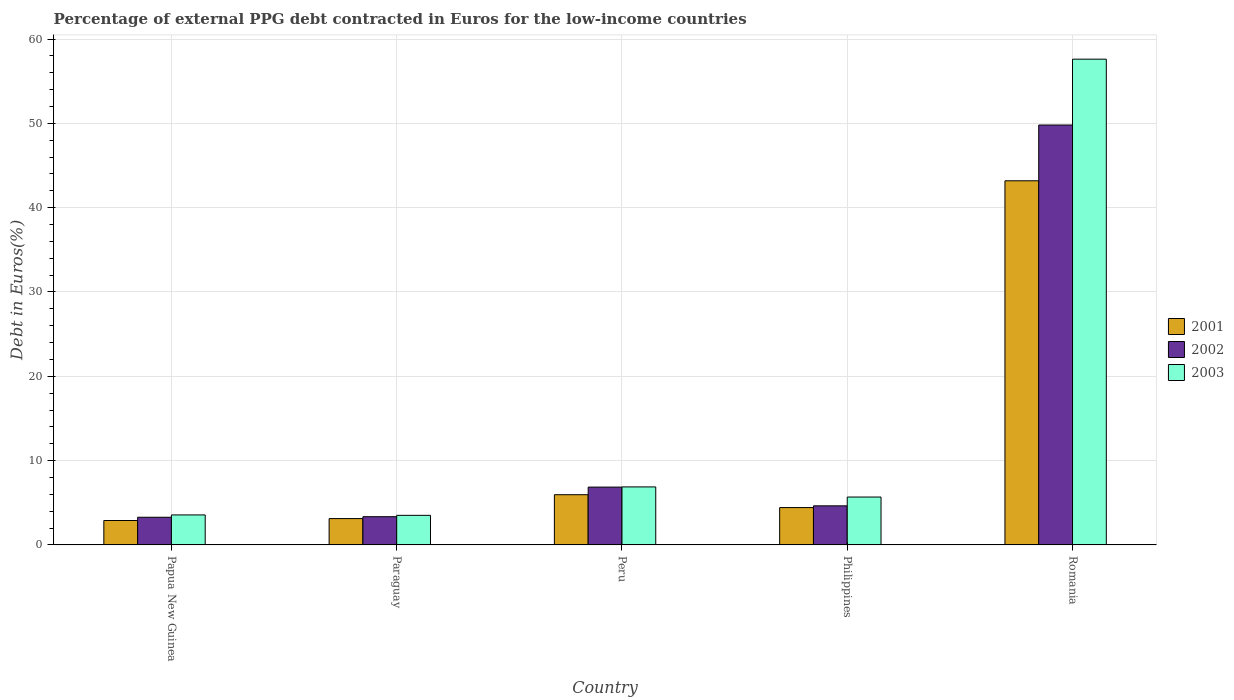Are the number of bars per tick equal to the number of legend labels?
Make the answer very short. Yes. Are the number of bars on each tick of the X-axis equal?
Provide a succinct answer. Yes. How many bars are there on the 3rd tick from the left?
Ensure brevity in your answer.  3. What is the label of the 2nd group of bars from the left?
Provide a short and direct response. Paraguay. In how many cases, is the number of bars for a given country not equal to the number of legend labels?
Ensure brevity in your answer.  0. What is the percentage of external PPG debt contracted in Euros in 2002 in Philippines?
Provide a succinct answer. 4.64. Across all countries, what is the maximum percentage of external PPG debt contracted in Euros in 2002?
Your answer should be compact. 49.8. Across all countries, what is the minimum percentage of external PPG debt contracted in Euros in 2002?
Your answer should be very brief. 3.28. In which country was the percentage of external PPG debt contracted in Euros in 2003 maximum?
Provide a short and direct response. Romania. In which country was the percentage of external PPG debt contracted in Euros in 2002 minimum?
Ensure brevity in your answer.  Papua New Guinea. What is the total percentage of external PPG debt contracted in Euros in 2001 in the graph?
Give a very brief answer. 59.6. What is the difference between the percentage of external PPG debt contracted in Euros in 2003 in Papua New Guinea and that in Romania?
Your answer should be very brief. -54.06. What is the difference between the percentage of external PPG debt contracted in Euros in 2001 in Romania and the percentage of external PPG debt contracted in Euros in 2002 in Paraguay?
Your answer should be compact. 39.84. What is the average percentage of external PPG debt contracted in Euros in 2003 per country?
Offer a terse response. 15.45. What is the difference between the percentage of external PPG debt contracted in Euros of/in 2002 and percentage of external PPG debt contracted in Euros of/in 2001 in Peru?
Your answer should be very brief. 0.9. What is the ratio of the percentage of external PPG debt contracted in Euros in 2002 in Philippines to that in Romania?
Provide a succinct answer. 0.09. Is the difference between the percentage of external PPG debt contracted in Euros in 2002 in Papua New Guinea and Romania greater than the difference between the percentage of external PPG debt contracted in Euros in 2001 in Papua New Guinea and Romania?
Offer a terse response. No. What is the difference between the highest and the second highest percentage of external PPG debt contracted in Euros in 2002?
Give a very brief answer. 45.17. What is the difference between the highest and the lowest percentage of external PPG debt contracted in Euros in 2003?
Your response must be concise. 54.1. In how many countries, is the percentage of external PPG debt contracted in Euros in 2003 greater than the average percentage of external PPG debt contracted in Euros in 2003 taken over all countries?
Keep it short and to the point. 1. What does the 1st bar from the left in Philippines represents?
Your answer should be compact. 2001. What does the 2nd bar from the right in Romania represents?
Your response must be concise. 2002. Are all the bars in the graph horizontal?
Provide a short and direct response. No. How many countries are there in the graph?
Ensure brevity in your answer.  5. What is the difference between two consecutive major ticks on the Y-axis?
Give a very brief answer. 10. Where does the legend appear in the graph?
Your answer should be very brief. Center right. What is the title of the graph?
Make the answer very short. Percentage of external PPG debt contracted in Euros for the low-income countries. What is the label or title of the Y-axis?
Provide a short and direct response. Debt in Euros(%). What is the Debt in Euros(%) of 2001 in Papua New Guinea?
Offer a very short reply. 2.9. What is the Debt in Euros(%) in 2002 in Papua New Guinea?
Your answer should be very brief. 3.28. What is the Debt in Euros(%) of 2003 in Papua New Guinea?
Keep it short and to the point. 3.56. What is the Debt in Euros(%) in 2001 in Paraguay?
Offer a terse response. 3.12. What is the Debt in Euros(%) in 2002 in Paraguay?
Offer a very short reply. 3.35. What is the Debt in Euros(%) of 2003 in Paraguay?
Provide a succinct answer. 3.51. What is the Debt in Euros(%) of 2001 in Peru?
Your answer should be compact. 5.96. What is the Debt in Euros(%) of 2002 in Peru?
Offer a very short reply. 6.86. What is the Debt in Euros(%) of 2003 in Peru?
Provide a succinct answer. 6.88. What is the Debt in Euros(%) of 2001 in Philippines?
Offer a terse response. 4.43. What is the Debt in Euros(%) of 2002 in Philippines?
Offer a terse response. 4.64. What is the Debt in Euros(%) in 2003 in Philippines?
Offer a very short reply. 5.68. What is the Debt in Euros(%) of 2001 in Romania?
Offer a very short reply. 43.19. What is the Debt in Euros(%) of 2002 in Romania?
Ensure brevity in your answer.  49.8. What is the Debt in Euros(%) of 2003 in Romania?
Your answer should be compact. 57.61. Across all countries, what is the maximum Debt in Euros(%) of 2001?
Provide a short and direct response. 43.19. Across all countries, what is the maximum Debt in Euros(%) of 2002?
Your answer should be very brief. 49.8. Across all countries, what is the maximum Debt in Euros(%) in 2003?
Your answer should be very brief. 57.61. Across all countries, what is the minimum Debt in Euros(%) in 2001?
Your response must be concise. 2.9. Across all countries, what is the minimum Debt in Euros(%) in 2002?
Provide a short and direct response. 3.28. Across all countries, what is the minimum Debt in Euros(%) of 2003?
Make the answer very short. 3.51. What is the total Debt in Euros(%) in 2001 in the graph?
Offer a very short reply. 59.6. What is the total Debt in Euros(%) in 2002 in the graph?
Give a very brief answer. 67.93. What is the total Debt in Euros(%) of 2003 in the graph?
Provide a short and direct response. 77.24. What is the difference between the Debt in Euros(%) in 2001 in Papua New Guinea and that in Paraguay?
Your response must be concise. -0.23. What is the difference between the Debt in Euros(%) of 2002 in Papua New Guinea and that in Paraguay?
Give a very brief answer. -0.07. What is the difference between the Debt in Euros(%) of 2003 in Papua New Guinea and that in Paraguay?
Offer a terse response. 0.05. What is the difference between the Debt in Euros(%) in 2001 in Papua New Guinea and that in Peru?
Provide a succinct answer. -3.06. What is the difference between the Debt in Euros(%) of 2002 in Papua New Guinea and that in Peru?
Offer a terse response. -3.58. What is the difference between the Debt in Euros(%) in 2003 in Papua New Guinea and that in Peru?
Give a very brief answer. -3.32. What is the difference between the Debt in Euros(%) of 2001 in Papua New Guinea and that in Philippines?
Provide a short and direct response. -1.53. What is the difference between the Debt in Euros(%) of 2002 in Papua New Guinea and that in Philippines?
Offer a terse response. -1.35. What is the difference between the Debt in Euros(%) in 2003 in Papua New Guinea and that in Philippines?
Provide a succinct answer. -2.12. What is the difference between the Debt in Euros(%) in 2001 in Papua New Guinea and that in Romania?
Give a very brief answer. -40.29. What is the difference between the Debt in Euros(%) in 2002 in Papua New Guinea and that in Romania?
Your answer should be very brief. -46.52. What is the difference between the Debt in Euros(%) in 2003 in Papua New Guinea and that in Romania?
Give a very brief answer. -54.06. What is the difference between the Debt in Euros(%) in 2001 in Paraguay and that in Peru?
Your answer should be compact. -2.83. What is the difference between the Debt in Euros(%) in 2002 in Paraguay and that in Peru?
Provide a succinct answer. -3.51. What is the difference between the Debt in Euros(%) in 2003 in Paraguay and that in Peru?
Make the answer very short. -3.37. What is the difference between the Debt in Euros(%) of 2001 in Paraguay and that in Philippines?
Offer a terse response. -1.31. What is the difference between the Debt in Euros(%) of 2002 in Paraguay and that in Philippines?
Give a very brief answer. -1.29. What is the difference between the Debt in Euros(%) in 2003 in Paraguay and that in Philippines?
Make the answer very short. -2.17. What is the difference between the Debt in Euros(%) in 2001 in Paraguay and that in Romania?
Your response must be concise. -40.06. What is the difference between the Debt in Euros(%) of 2002 in Paraguay and that in Romania?
Make the answer very short. -46.45. What is the difference between the Debt in Euros(%) of 2003 in Paraguay and that in Romania?
Provide a short and direct response. -54.1. What is the difference between the Debt in Euros(%) of 2001 in Peru and that in Philippines?
Provide a short and direct response. 1.53. What is the difference between the Debt in Euros(%) in 2002 in Peru and that in Philippines?
Give a very brief answer. 2.22. What is the difference between the Debt in Euros(%) in 2003 in Peru and that in Philippines?
Ensure brevity in your answer.  1.2. What is the difference between the Debt in Euros(%) of 2001 in Peru and that in Romania?
Offer a terse response. -37.23. What is the difference between the Debt in Euros(%) in 2002 in Peru and that in Romania?
Your answer should be compact. -42.94. What is the difference between the Debt in Euros(%) in 2003 in Peru and that in Romania?
Make the answer very short. -50.73. What is the difference between the Debt in Euros(%) of 2001 in Philippines and that in Romania?
Offer a terse response. -38.76. What is the difference between the Debt in Euros(%) in 2002 in Philippines and that in Romania?
Keep it short and to the point. -45.17. What is the difference between the Debt in Euros(%) of 2003 in Philippines and that in Romania?
Offer a very short reply. -51.93. What is the difference between the Debt in Euros(%) of 2001 in Papua New Guinea and the Debt in Euros(%) of 2002 in Paraguay?
Provide a short and direct response. -0.45. What is the difference between the Debt in Euros(%) in 2001 in Papua New Guinea and the Debt in Euros(%) in 2003 in Paraguay?
Your answer should be compact. -0.61. What is the difference between the Debt in Euros(%) in 2002 in Papua New Guinea and the Debt in Euros(%) in 2003 in Paraguay?
Offer a terse response. -0.23. What is the difference between the Debt in Euros(%) in 2001 in Papua New Guinea and the Debt in Euros(%) in 2002 in Peru?
Your response must be concise. -3.96. What is the difference between the Debt in Euros(%) in 2001 in Papua New Guinea and the Debt in Euros(%) in 2003 in Peru?
Ensure brevity in your answer.  -3.98. What is the difference between the Debt in Euros(%) of 2002 in Papua New Guinea and the Debt in Euros(%) of 2003 in Peru?
Make the answer very short. -3.6. What is the difference between the Debt in Euros(%) in 2001 in Papua New Guinea and the Debt in Euros(%) in 2002 in Philippines?
Your answer should be compact. -1.74. What is the difference between the Debt in Euros(%) in 2001 in Papua New Guinea and the Debt in Euros(%) in 2003 in Philippines?
Ensure brevity in your answer.  -2.78. What is the difference between the Debt in Euros(%) of 2002 in Papua New Guinea and the Debt in Euros(%) of 2003 in Philippines?
Your answer should be very brief. -2.4. What is the difference between the Debt in Euros(%) of 2001 in Papua New Guinea and the Debt in Euros(%) of 2002 in Romania?
Your answer should be very brief. -46.91. What is the difference between the Debt in Euros(%) of 2001 in Papua New Guinea and the Debt in Euros(%) of 2003 in Romania?
Offer a terse response. -54.72. What is the difference between the Debt in Euros(%) of 2002 in Papua New Guinea and the Debt in Euros(%) of 2003 in Romania?
Give a very brief answer. -54.33. What is the difference between the Debt in Euros(%) of 2001 in Paraguay and the Debt in Euros(%) of 2002 in Peru?
Your response must be concise. -3.73. What is the difference between the Debt in Euros(%) in 2001 in Paraguay and the Debt in Euros(%) in 2003 in Peru?
Offer a terse response. -3.76. What is the difference between the Debt in Euros(%) of 2002 in Paraguay and the Debt in Euros(%) of 2003 in Peru?
Make the answer very short. -3.53. What is the difference between the Debt in Euros(%) of 2001 in Paraguay and the Debt in Euros(%) of 2002 in Philippines?
Your answer should be very brief. -1.51. What is the difference between the Debt in Euros(%) of 2001 in Paraguay and the Debt in Euros(%) of 2003 in Philippines?
Your answer should be very brief. -2.56. What is the difference between the Debt in Euros(%) in 2002 in Paraguay and the Debt in Euros(%) in 2003 in Philippines?
Keep it short and to the point. -2.33. What is the difference between the Debt in Euros(%) in 2001 in Paraguay and the Debt in Euros(%) in 2002 in Romania?
Keep it short and to the point. -46.68. What is the difference between the Debt in Euros(%) in 2001 in Paraguay and the Debt in Euros(%) in 2003 in Romania?
Make the answer very short. -54.49. What is the difference between the Debt in Euros(%) of 2002 in Paraguay and the Debt in Euros(%) of 2003 in Romania?
Keep it short and to the point. -54.26. What is the difference between the Debt in Euros(%) of 2001 in Peru and the Debt in Euros(%) of 2002 in Philippines?
Offer a terse response. 1.32. What is the difference between the Debt in Euros(%) in 2001 in Peru and the Debt in Euros(%) in 2003 in Philippines?
Provide a succinct answer. 0.28. What is the difference between the Debt in Euros(%) in 2002 in Peru and the Debt in Euros(%) in 2003 in Philippines?
Offer a very short reply. 1.18. What is the difference between the Debt in Euros(%) in 2001 in Peru and the Debt in Euros(%) in 2002 in Romania?
Give a very brief answer. -43.85. What is the difference between the Debt in Euros(%) of 2001 in Peru and the Debt in Euros(%) of 2003 in Romania?
Keep it short and to the point. -51.66. What is the difference between the Debt in Euros(%) of 2002 in Peru and the Debt in Euros(%) of 2003 in Romania?
Keep it short and to the point. -50.76. What is the difference between the Debt in Euros(%) of 2001 in Philippines and the Debt in Euros(%) of 2002 in Romania?
Your answer should be very brief. -45.37. What is the difference between the Debt in Euros(%) in 2001 in Philippines and the Debt in Euros(%) in 2003 in Romania?
Provide a succinct answer. -53.18. What is the difference between the Debt in Euros(%) of 2002 in Philippines and the Debt in Euros(%) of 2003 in Romania?
Offer a terse response. -52.98. What is the average Debt in Euros(%) in 2001 per country?
Offer a very short reply. 11.92. What is the average Debt in Euros(%) in 2002 per country?
Offer a terse response. 13.59. What is the average Debt in Euros(%) in 2003 per country?
Offer a very short reply. 15.45. What is the difference between the Debt in Euros(%) in 2001 and Debt in Euros(%) in 2002 in Papua New Guinea?
Give a very brief answer. -0.39. What is the difference between the Debt in Euros(%) in 2001 and Debt in Euros(%) in 2003 in Papua New Guinea?
Your response must be concise. -0.66. What is the difference between the Debt in Euros(%) in 2002 and Debt in Euros(%) in 2003 in Papua New Guinea?
Give a very brief answer. -0.27. What is the difference between the Debt in Euros(%) of 2001 and Debt in Euros(%) of 2002 in Paraguay?
Offer a terse response. -0.22. What is the difference between the Debt in Euros(%) in 2001 and Debt in Euros(%) in 2003 in Paraguay?
Make the answer very short. -0.39. What is the difference between the Debt in Euros(%) of 2002 and Debt in Euros(%) of 2003 in Paraguay?
Make the answer very short. -0.16. What is the difference between the Debt in Euros(%) of 2001 and Debt in Euros(%) of 2002 in Peru?
Your answer should be very brief. -0.9. What is the difference between the Debt in Euros(%) of 2001 and Debt in Euros(%) of 2003 in Peru?
Your response must be concise. -0.92. What is the difference between the Debt in Euros(%) of 2002 and Debt in Euros(%) of 2003 in Peru?
Ensure brevity in your answer.  -0.02. What is the difference between the Debt in Euros(%) of 2001 and Debt in Euros(%) of 2002 in Philippines?
Provide a short and direct response. -0.21. What is the difference between the Debt in Euros(%) of 2001 and Debt in Euros(%) of 2003 in Philippines?
Keep it short and to the point. -1.25. What is the difference between the Debt in Euros(%) in 2002 and Debt in Euros(%) in 2003 in Philippines?
Give a very brief answer. -1.04. What is the difference between the Debt in Euros(%) in 2001 and Debt in Euros(%) in 2002 in Romania?
Your answer should be compact. -6.61. What is the difference between the Debt in Euros(%) of 2001 and Debt in Euros(%) of 2003 in Romania?
Offer a very short reply. -14.43. What is the difference between the Debt in Euros(%) of 2002 and Debt in Euros(%) of 2003 in Romania?
Your answer should be very brief. -7.81. What is the ratio of the Debt in Euros(%) in 2001 in Papua New Guinea to that in Paraguay?
Your answer should be very brief. 0.93. What is the ratio of the Debt in Euros(%) in 2002 in Papua New Guinea to that in Paraguay?
Give a very brief answer. 0.98. What is the ratio of the Debt in Euros(%) in 2003 in Papua New Guinea to that in Paraguay?
Offer a very short reply. 1.01. What is the ratio of the Debt in Euros(%) of 2001 in Papua New Guinea to that in Peru?
Provide a short and direct response. 0.49. What is the ratio of the Debt in Euros(%) of 2002 in Papua New Guinea to that in Peru?
Your response must be concise. 0.48. What is the ratio of the Debt in Euros(%) in 2003 in Papua New Guinea to that in Peru?
Offer a very short reply. 0.52. What is the ratio of the Debt in Euros(%) in 2001 in Papua New Guinea to that in Philippines?
Your response must be concise. 0.65. What is the ratio of the Debt in Euros(%) in 2002 in Papua New Guinea to that in Philippines?
Your response must be concise. 0.71. What is the ratio of the Debt in Euros(%) of 2003 in Papua New Guinea to that in Philippines?
Give a very brief answer. 0.63. What is the ratio of the Debt in Euros(%) of 2001 in Papua New Guinea to that in Romania?
Make the answer very short. 0.07. What is the ratio of the Debt in Euros(%) of 2002 in Papua New Guinea to that in Romania?
Offer a very short reply. 0.07. What is the ratio of the Debt in Euros(%) of 2003 in Papua New Guinea to that in Romania?
Provide a succinct answer. 0.06. What is the ratio of the Debt in Euros(%) of 2001 in Paraguay to that in Peru?
Provide a succinct answer. 0.52. What is the ratio of the Debt in Euros(%) in 2002 in Paraguay to that in Peru?
Give a very brief answer. 0.49. What is the ratio of the Debt in Euros(%) of 2003 in Paraguay to that in Peru?
Provide a short and direct response. 0.51. What is the ratio of the Debt in Euros(%) of 2001 in Paraguay to that in Philippines?
Keep it short and to the point. 0.71. What is the ratio of the Debt in Euros(%) in 2002 in Paraguay to that in Philippines?
Your answer should be compact. 0.72. What is the ratio of the Debt in Euros(%) in 2003 in Paraguay to that in Philippines?
Provide a succinct answer. 0.62. What is the ratio of the Debt in Euros(%) in 2001 in Paraguay to that in Romania?
Offer a very short reply. 0.07. What is the ratio of the Debt in Euros(%) in 2002 in Paraguay to that in Romania?
Keep it short and to the point. 0.07. What is the ratio of the Debt in Euros(%) in 2003 in Paraguay to that in Romania?
Provide a succinct answer. 0.06. What is the ratio of the Debt in Euros(%) of 2001 in Peru to that in Philippines?
Your answer should be very brief. 1.34. What is the ratio of the Debt in Euros(%) in 2002 in Peru to that in Philippines?
Provide a succinct answer. 1.48. What is the ratio of the Debt in Euros(%) in 2003 in Peru to that in Philippines?
Make the answer very short. 1.21. What is the ratio of the Debt in Euros(%) of 2001 in Peru to that in Romania?
Provide a succinct answer. 0.14. What is the ratio of the Debt in Euros(%) of 2002 in Peru to that in Romania?
Provide a succinct answer. 0.14. What is the ratio of the Debt in Euros(%) of 2003 in Peru to that in Romania?
Your response must be concise. 0.12. What is the ratio of the Debt in Euros(%) in 2001 in Philippines to that in Romania?
Ensure brevity in your answer.  0.1. What is the ratio of the Debt in Euros(%) in 2002 in Philippines to that in Romania?
Your answer should be very brief. 0.09. What is the ratio of the Debt in Euros(%) in 2003 in Philippines to that in Romania?
Offer a terse response. 0.1. What is the difference between the highest and the second highest Debt in Euros(%) of 2001?
Ensure brevity in your answer.  37.23. What is the difference between the highest and the second highest Debt in Euros(%) in 2002?
Offer a very short reply. 42.94. What is the difference between the highest and the second highest Debt in Euros(%) of 2003?
Offer a very short reply. 50.73. What is the difference between the highest and the lowest Debt in Euros(%) in 2001?
Give a very brief answer. 40.29. What is the difference between the highest and the lowest Debt in Euros(%) of 2002?
Make the answer very short. 46.52. What is the difference between the highest and the lowest Debt in Euros(%) of 2003?
Your answer should be very brief. 54.1. 